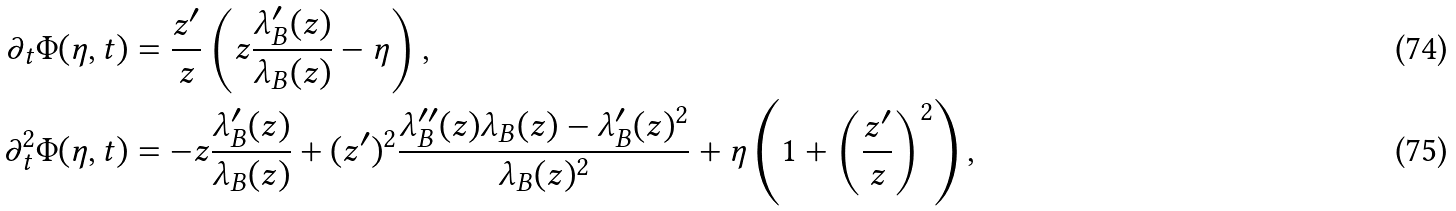<formula> <loc_0><loc_0><loc_500><loc_500>\partial _ { t } \Phi ( \eta , t ) & = \frac { z ^ { \prime } } { z } \left ( z \frac { \lambda _ { B } ^ { \prime } ( z ) } { \lambda _ { B } ( z ) } - \eta \right ) , \\ \partial _ { t } ^ { 2 } \Phi ( \eta , t ) & = - z \frac { \lambda _ { B } ^ { \prime } ( z ) } { \lambda _ { B } ( z ) } + ( z ^ { \prime } ) ^ { 2 } \frac { \lambda _ { B } ^ { \prime \prime } ( z ) \lambda _ { B } ( z ) - \lambda _ { B } ^ { \prime } ( z ) ^ { 2 } } { \lambda _ { B } ( z ) ^ { 2 } } + \eta \left ( 1 + \left ( \frac { z ^ { \prime } } { z } \right ) ^ { 2 } \right ) ,</formula> 